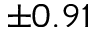<formula> <loc_0><loc_0><loc_500><loc_500>\pm 0 . 9 1</formula> 